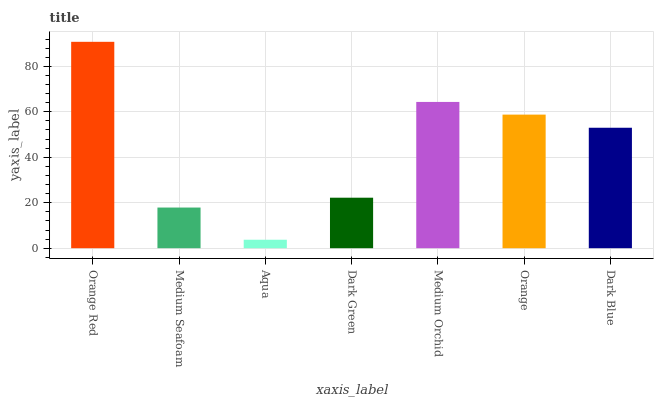Is Aqua the minimum?
Answer yes or no. Yes. Is Orange Red the maximum?
Answer yes or no. Yes. Is Medium Seafoam the minimum?
Answer yes or no. No. Is Medium Seafoam the maximum?
Answer yes or no. No. Is Orange Red greater than Medium Seafoam?
Answer yes or no. Yes. Is Medium Seafoam less than Orange Red?
Answer yes or no. Yes. Is Medium Seafoam greater than Orange Red?
Answer yes or no. No. Is Orange Red less than Medium Seafoam?
Answer yes or no. No. Is Dark Blue the high median?
Answer yes or no. Yes. Is Dark Blue the low median?
Answer yes or no. Yes. Is Medium Orchid the high median?
Answer yes or no. No. Is Dark Green the low median?
Answer yes or no. No. 